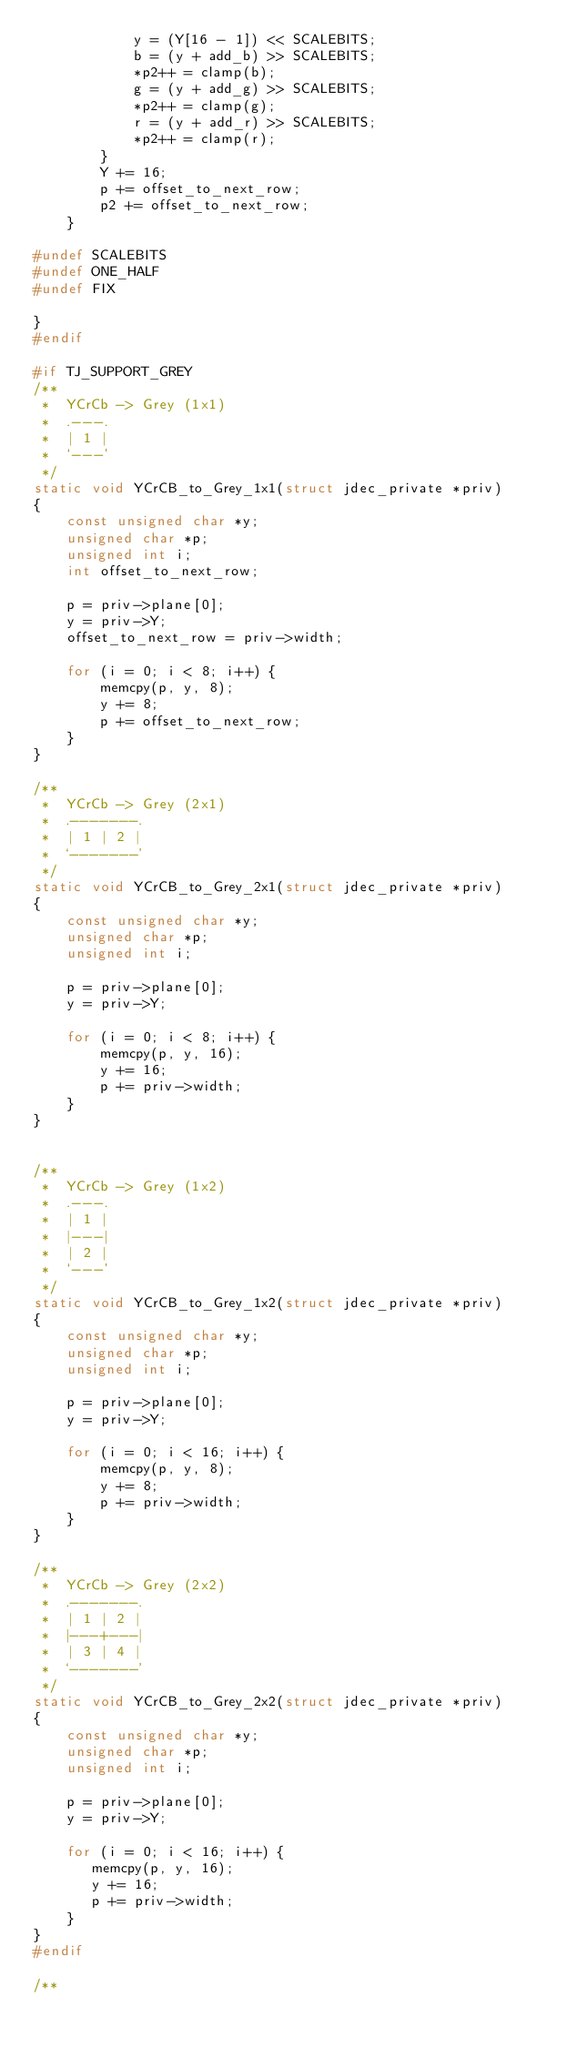<code> <loc_0><loc_0><loc_500><loc_500><_C_>            y = (Y[16 - 1]) << SCALEBITS;
            b = (y + add_b) >> SCALEBITS;
            *p2++ = clamp(b);
            g = (y + add_g) >> SCALEBITS;
            *p2++ = clamp(g);
            r = (y + add_r) >> SCALEBITS;
            *p2++ = clamp(r);
        }
        Y += 16;
        p += offset_to_next_row;
        p2 += offset_to_next_row;
    }

#undef SCALEBITS
#undef ONE_HALF
#undef FIX

}
#endif

#if TJ_SUPPORT_GREY
/**
 *  YCrCb -> Grey (1x1)
 *  .---.
 *  | 1 |
 *  `---'
 */
static void YCrCB_to_Grey_1x1(struct jdec_private *priv)
{
    const unsigned char *y;
    unsigned char *p;
    unsigned int i;
    int offset_to_next_row;

    p = priv->plane[0];
    y = priv->Y;
    offset_to_next_row = priv->width;

    for (i = 0; i < 8; i++) {
        memcpy(p, y, 8);
        y += 8;
        p += offset_to_next_row;
    }
}

/**
 *  YCrCb -> Grey (2x1)
 *  .-------.
 *  | 1 | 2 |
 *  `-------'
 */
static void YCrCB_to_Grey_2x1(struct jdec_private *priv)
{
    const unsigned char *y;
    unsigned char *p;
    unsigned int i;

    p = priv->plane[0];
    y = priv->Y;

    for (i = 0; i < 8; i++) {
        memcpy(p, y, 16);
        y += 16;
        p += priv->width;
    }
}


/**
 *  YCrCb -> Grey (1x2)
 *  .---.
 *  | 1 |
 *  |---|
 *  | 2 |
 *  `---'
 */
static void YCrCB_to_Grey_1x2(struct jdec_private *priv)
{
    const unsigned char *y;
    unsigned char *p;
    unsigned int i;

    p = priv->plane[0];
    y = priv->Y;

    for (i = 0; i < 16; i++) {
        memcpy(p, y, 8);
        y += 8;
        p += priv->width;
    }
}

/**
 *  YCrCb -> Grey (2x2)
 *  .-------.
 *  | 1 | 2 |
 *  |---+---|
 *  | 3 | 4 |
 *  `-------'
 */
static void YCrCB_to_Grey_2x2(struct jdec_private *priv)
{
    const unsigned char *y;
    unsigned char *p;
    unsigned int i;

    p = priv->plane[0];
    y = priv->Y;

    for (i = 0; i < 16; i++) {
       memcpy(p, y, 16);
       y += 16;
       p += priv->width;
    }
}
#endif

/**</code> 